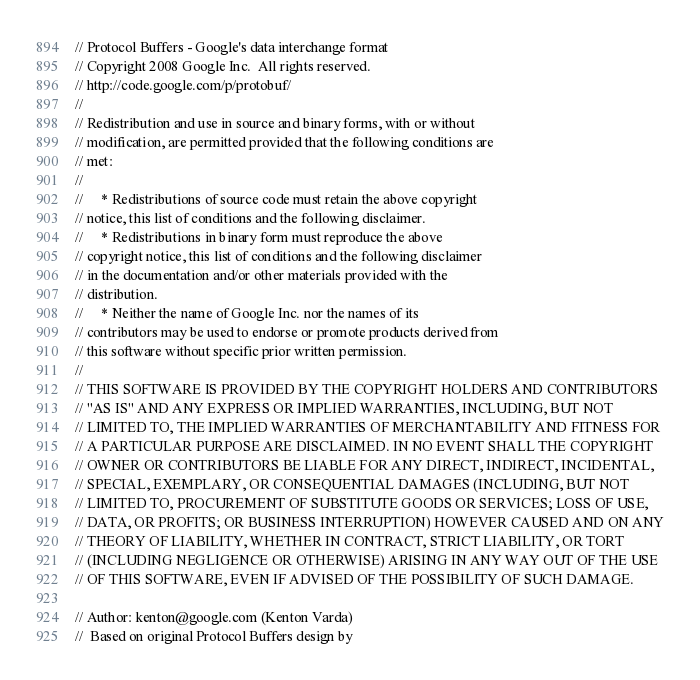<code> <loc_0><loc_0><loc_500><loc_500><_C_>// Protocol Buffers - Google's data interchange format
// Copyright 2008 Google Inc.  All rights reserved.
// http://code.google.com/p/protobuf/
//
// Redistribution and use in source and binary forms, with or without
// modification, are permitted provided that the following conditions are
// met:
//
//     * Redistributions of source code must retain the above copyright
// notice, this list of conditions and the following disclaimer.
//     * Redistributions in binary form must reproduce the above
// copyright notice, this list of conditions and the following disclaimer
// in the documentation and/or other materials provided with the
// distribution.
//     * Neither the name of Google Inc. nor the names of its
// contributors may be used to endorse or promote products derived from
// this software without specific prior written permission.
//
// THIS SOFTWARE IS PROVIDED BY THE COPYRIGHT HOLDERS AND CONTRIBUTORS
// "AS IS" AND ANY EXPRESS OR IMPLIED WARRANTIES, INCLUDING, BUT NOT
// LIMITED TO, THE IMPLIED WARRANTIES OF MERCHANTABILITY AND FITNESS FOR
// A PARTICULAR PURPOSE ARE DISCLAIMED. IN NO EVENT SHALL THE COPYRIGHT
// OWNER OR CONTRIBUTORS BE LIABLE FOR ANY DIRECT, INDIRECT, INCIDENTAL,
// SPECIAL, EXEMPLARY, OR CONSEQUENTIAL DAMAGES (INCLUDING, BUT NOT
// LIMITED TO, PROCUREMENT OF SUBSTITUTE GOODS OR SERVICES; LOSS OF USE,
// DATA, OR PROFITS; OR BUSINESS INTERRUPTION) HOWEVER CAUSED AND ON ANY
// THEORY OF LIABILITY, WHETHER IN CONTRACT, STRICT LIABILITY, OR TORT
// (INCLUDING NEGLIGENCE OR OTHERWISE) ARISING IN ANY WAY OUT OF THE USE
// OF THIS SOFTWARE, EVEN IF ADVISED OF THE POSSIBILITY OF SUCH DAMAGE.

// Author: kenton@google.com (Kenton Varda)
//  Based on original Protocol Buffers design by</code> 